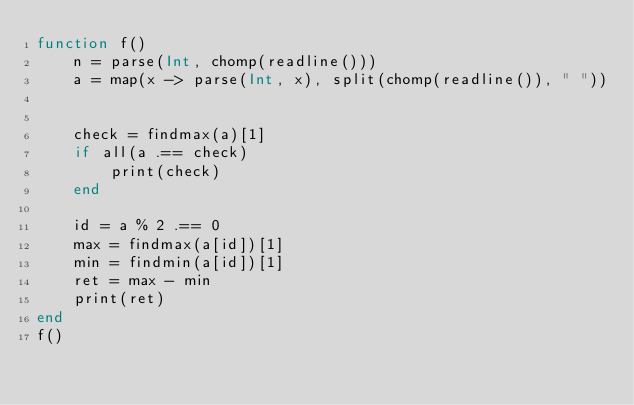Convert code to text. <code><loc_0><loc_0><loc_500><loc_500><_Julia_>function f()
    n = parse(Int, chomp(readline()))
    a = map(x -> parse(Int, x), split(chomp(readline()), " "))


    check = findmax(a)[1]
    if all(a .== check)
        print(check)
    end

    id = a % 2 .== 0
    max = findmax(a[id])[1]
    min = findmin(a[id])[1]
    ret = max - min
    print(ret)
end
f()</code> 